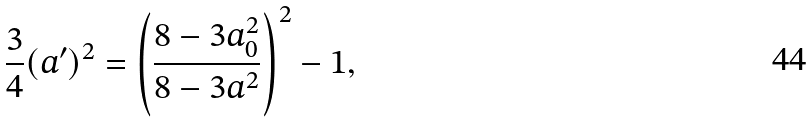<formula> <loc_0><loc_0><loc_500><loc_500>\frac { 3 } { 4 } ( a ^ { \prime } ) ^ { 2 } = \left ( \frac { 8 - 3 a _ { 0 } ^ { 2 } } { 8 - 3 a ^ { 2 } } \right ) ^ { 2 } - 1 ,</formula> 